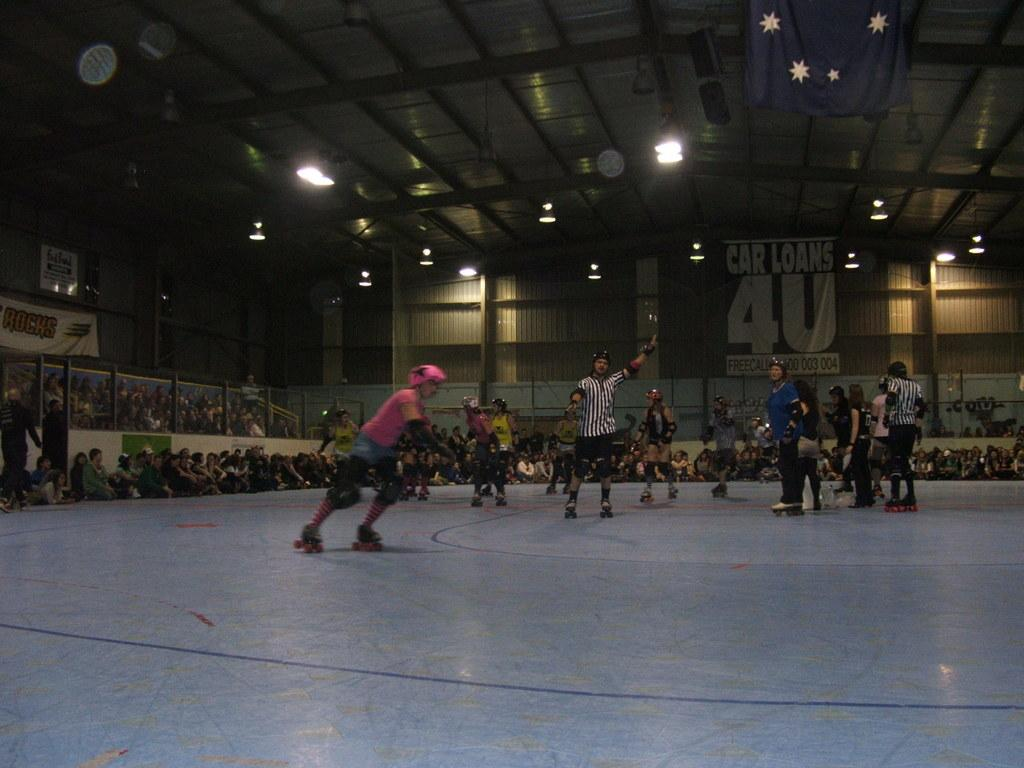What are the people in the image doing? The people in the image are skating on the floor. Can you describe the background of the image? In the background, there are people, poles, walls, banners, lights, and cloths. What might the poles be used for in the image? The poles in the background might be used for supporting banners or lights. How many elements in the background contribute to the overall atmosphere of the image? The banners, lights, and cloths in the background create a festive or event-like atmosphere. What type of chalk is being used to draw on the floor by the skaters in the image? There is no chalk visible in the image, and the skaters are not drawing on the floor. Can you see any sails in the image? There are no sails present in the image. 